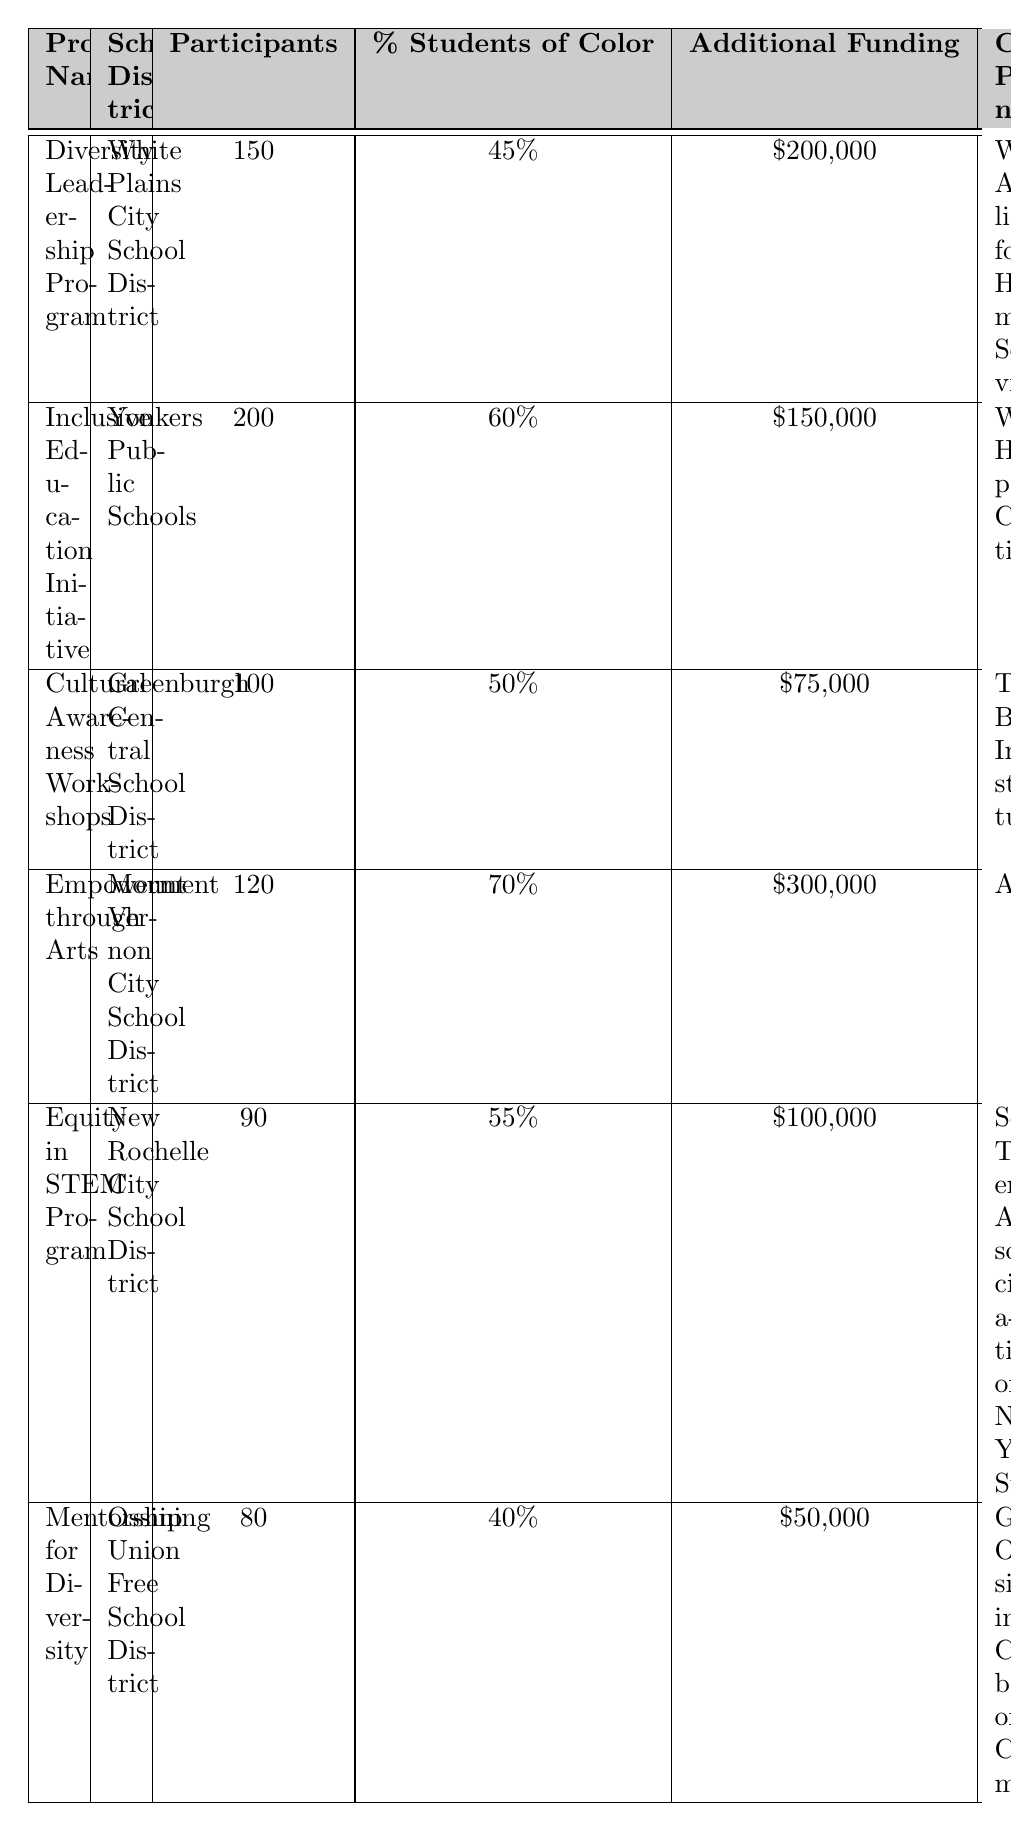What is the highest impact rating in the table? The highest impact rating can be found by looking through the "Impact Rating" column. The maximum number listed is 4.8, associated with the "Inclusive Education Initiative."
Answer: 4.8 Which program had the least number of participants? The program with the least number of participants can be identified by comparing the "Participants" column. The "Mentorship for Diversity" program had 80 participants, which is the lowest.
Answer: 80 What is the total additional funding provided to all programs? To find the total additional funding, add up the individual funding amounts: $200,000 + $150,000 + $75,000 + $300,000 + $100,000 + $50,000 = $875,000.
Answer: $875,000 What percentage of students of color is represented in the "Empowerment through Arts" program? The percentage of students of color in the "Empowerment through Arts" program is directly listed in the table under the "% Students of Color" column, which is 70%.
Answer: 70% How many more participants are in the "Inclusive Education Initiative" compared to the "Mentorship for Diversity"? To find the difference between the participants, subtract the number of participants in "Mentorship for Diversity" (80) from "Inclusive Education Initiative" (200): 200 - 80 = 120.
Answer: 120 Is the "Cultural Awareness Workshops" program rated higher than 4.5? By checking the "Impact Rating" for "Cultural Awareness Workshops," which is 4.0, we see that it is not higher than 4.5, thus the answer is no.
Answer: No What is the average percentage of students of color across all programs? To calculate the average percentage of students of color, sum the percentages (45 + 60 + 50 + 70 + 55 + 40 = 320) and divide by the number of programs (6): 320 / 6 = 53.33%.
Answer: 53.33% Which school district had the highest percentage of students of color? To find the highest percentage, check each "% Students of Color" entry. "Mount Vernon City School District" had the highest at 70%.
Answer: Mount Vernon City School District How many programs had an impact rating of 4.5 or higher? The impact ratings of each program are checked: 4.5, 4.8, 4.0, 4.6, 4.2, and 3.9. The programs with ratings of 4.5 or higher are "Diversity Leadership Program," "Inclusive Education Initiative," "Empowerment through Arts," and "Equity in STEM Program." That's four programs.
Answer: 4 What is the funding difference between the "Empowerment through Arts" program and the "Mentorship for Diversity"? The funding for "Empowerment through Arts" is $300,000 and for "Mentorship for Diversity" is $50,000. The difference is calculated by subtracting: $300,000 - $50,000 = $250,000.
Answer: $250,000 